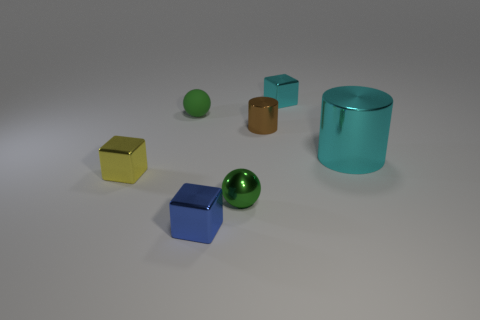Subtract all blue blocks. How many blocks are left? 2 Subtract 1 cylinders. How many cylinders are left? 1 Subtract all blue cubes. How many cubes are left? 2 Add 1 tiny metal cylinders. How many objects exist? 8 Subtract all brown cylinders. How many brown balls are left? 0 Subtract all big cyan shiny cylinders. Subtract all brown matte objects. How many objects are left? 6 Add 6 big cylinders. How many big cylinders are left? 7 Add 1 large rubber cubes. How many large rubber cubes exist? 1 Subtract 0 purple blocks. How many objects are left? 7 Subtract all cylinders. How many objects are left? 5 